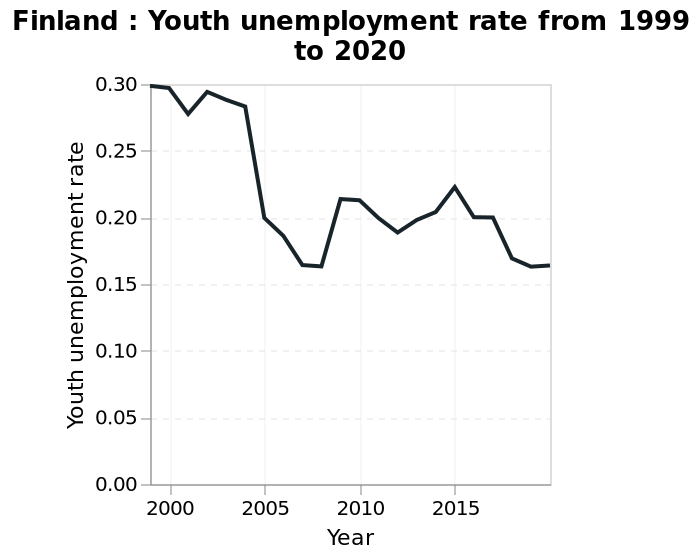<image>
Were there any exceptions to the decreasing trend in youth unemployment rate?  Yes, there were exceptions to the decreasing trend. The youth unemployment rate rose in 2009. Offer a thorough analysis of the image. Youth unemployment rate has gradually decreased since 1999, though rises in 2009 and rising again between 2012 and 2015. What time period does the line diagram span? The line diagram spans from 1999 to 2020, indicating the years in which the youth unemployment rate data is represented. What is the scale range along the x-axis on the line diagram? The scale range along the x-axis is from 2000 to 2015, marked as Year. 